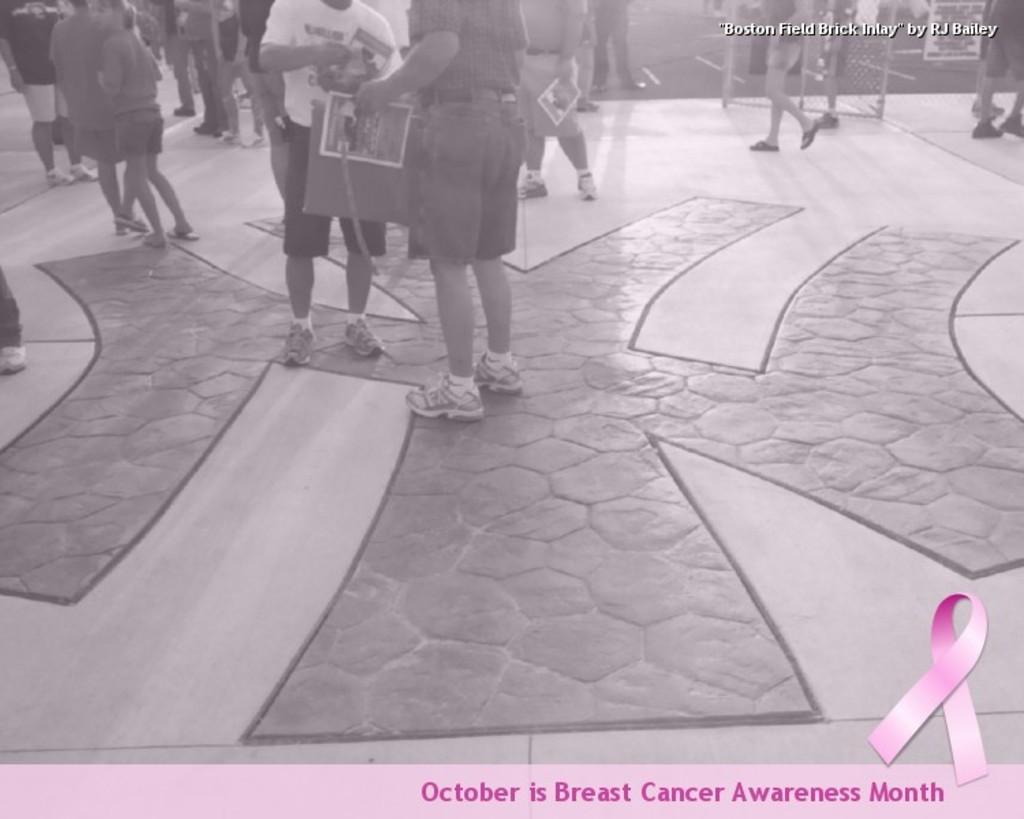Please provide a concise description of this image. This picture is an edited picture. In this image there are group of people, few are standing and holding the posters and few are walking. At the top right there is a text. At bottom there is a floor. At the bottom right there is a text. 